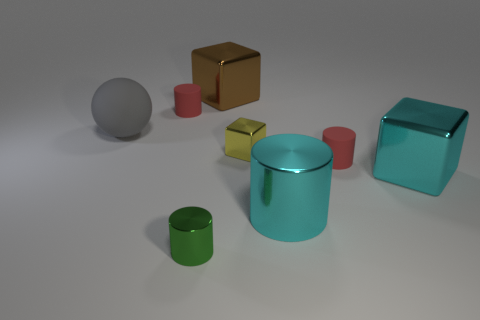The cyan thing that is the same shape as the tiny green thing is what size?
Provide a succinct answer. Large. The matte object right of the metal cylinder on the left side of the cyan cylinder is what shape?
Your response must be concise. Cylinder. What number of blue objects are rubber cylinders or rubber balls?
Your response must be concise. 0. The small metallic cylinder has what color?
Provide a short and direct response. Green. Is the cyan metal block the same size as the matte sphere?
Offer a very short reply. Yes. Is there any other thing that is the same shape as the large brown metal object?
Provide a succinct answer. Yes. Is the material of the large gray ball the same as the large block in front of the brown metallic thing?
Your response must be concise. No. There is a large metal block that is in front of the large gray matte sphere; is it the same color as the large shiny cylinder?
Offer a very short reply. Yes. What number of small cylinders are right of the brown thing and in front of the big cyan block?
Offer a very short reply. 0. How many other things are made of the same material as the big cylinder?
Your response must be concise. 4. 